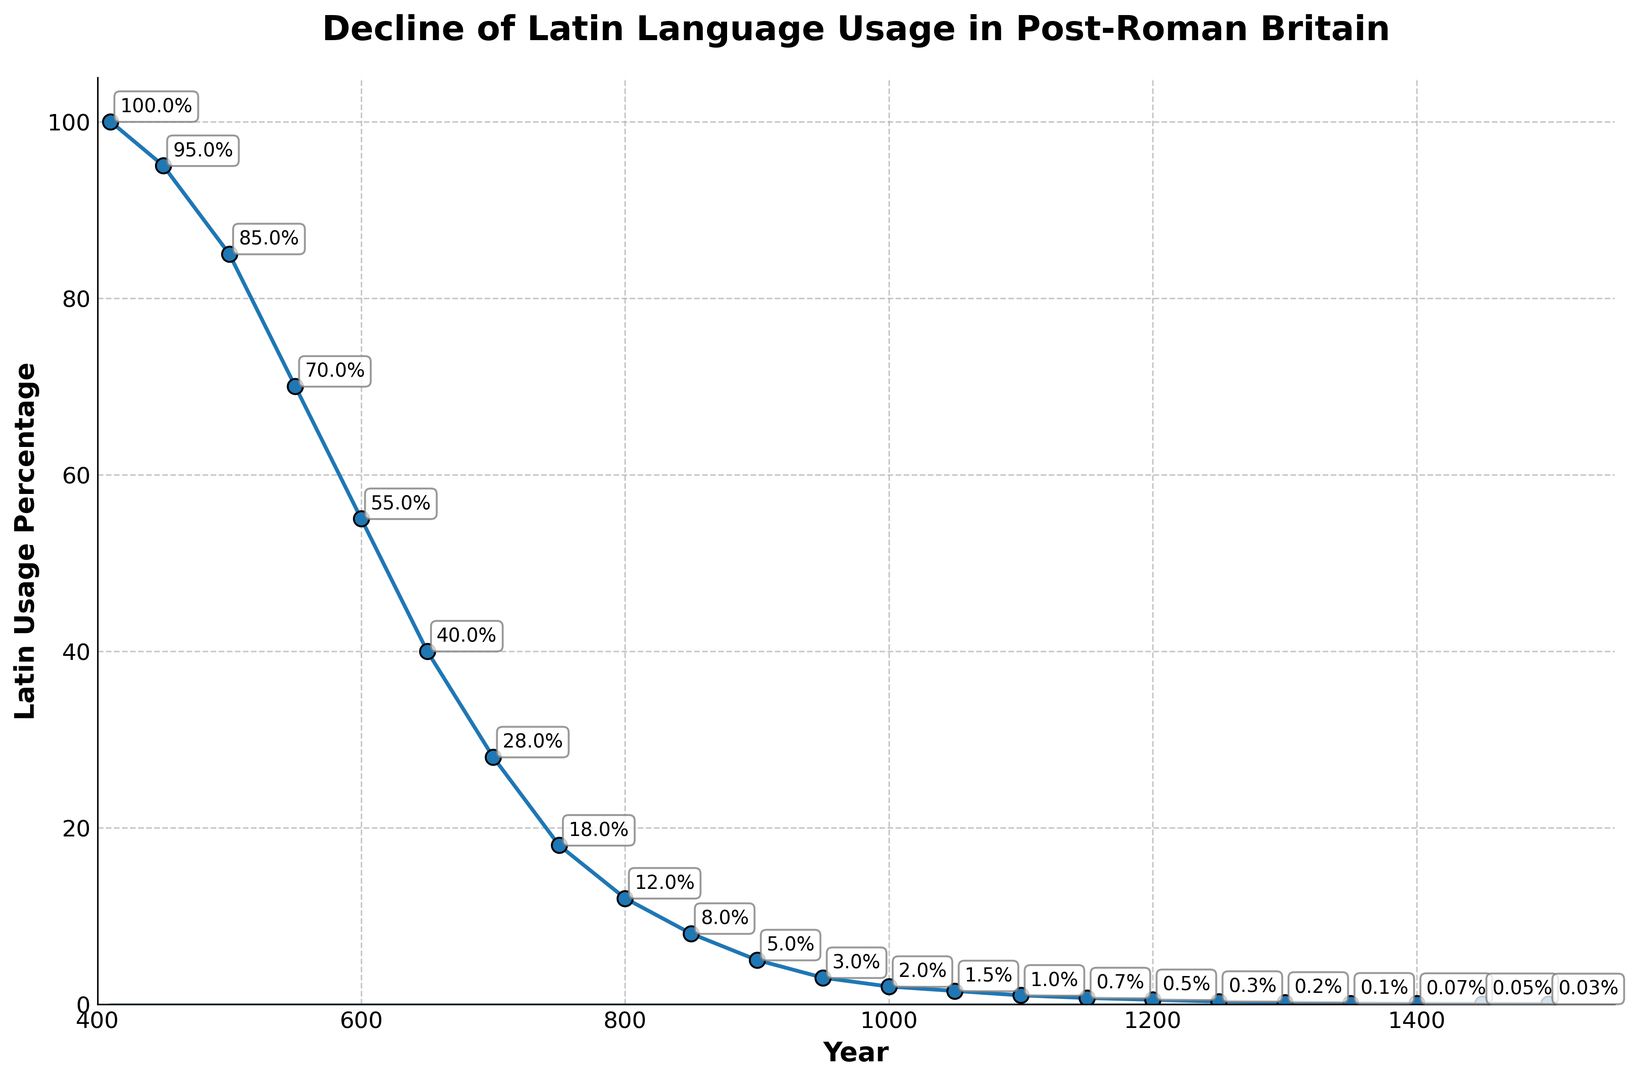What is the Latin usage percentage around the year 500? By looking at the trend on the graph near the year 500, the Latin usage percentage is around 85%.
Answer: 85% Between which two years does the most significant decline in Latin usage occur? Observing the slope of the curve, the steepest decline occurs between 500 and 550, where Latin usage drops from 85% to 70%.
Answer: 500 and 550 By how much did Latin usage decline from the year 450 to the year 900? Referring to the graph, the Latin usage decreased from 95% in 450 to 5% in 900. Subtract 5 from 95: 95% - 5% = 90%.
Answer: 90% What is the percentage decrease in Latin usage from 600 to 700? Usage dropped from 55% to 28% between these years. Calculating percentage decrease: ((55 - 28) / 55) * 100 = 49.1%.
Answer: 49.1% Which year marks the point when Latin usage falls below 50%? According to the graph, the first time Latin usage falls below 50% is in the year 600.
Answer: 600 What is the difference in Latin usage percentages between the years 1000 and 1100? The Latin usage percentage in 1000 is 2% and in 1100 it is 1%. Subtracting these values gives: 2% - 1% = 1%.
Answer: 1% How does the decline from 950 to 1000 compare to the decline from 1000 to 1050? Decline from 950 to 1000 is from 3% to 2% (1%), and from 1000 to 1050 is from 2% to 1.5% (0.5%). The decline from 950 to 1000 is greater.
Answer: 950 to 1000 What color represents the filled area under the curve in the chart? The filled area under the curve is shaded in blue.
Answer: Blue Looking at the trend, around which century did Latin usage drop by about half from its initial value of 100%? By examining the overall trend, the Latin usage percentage drops to approximately 50% around the 6th century (about the year 600).
Answer: 6th century By how much did the percentage of Latin usage decline from 1200 to 1400? Latin usage declined from 0.5% in 1200 to approximately 0.07% in 1400. Subtracting these gives 0.5% - 0.07% = 0.43%.
Answer: 0.43% 